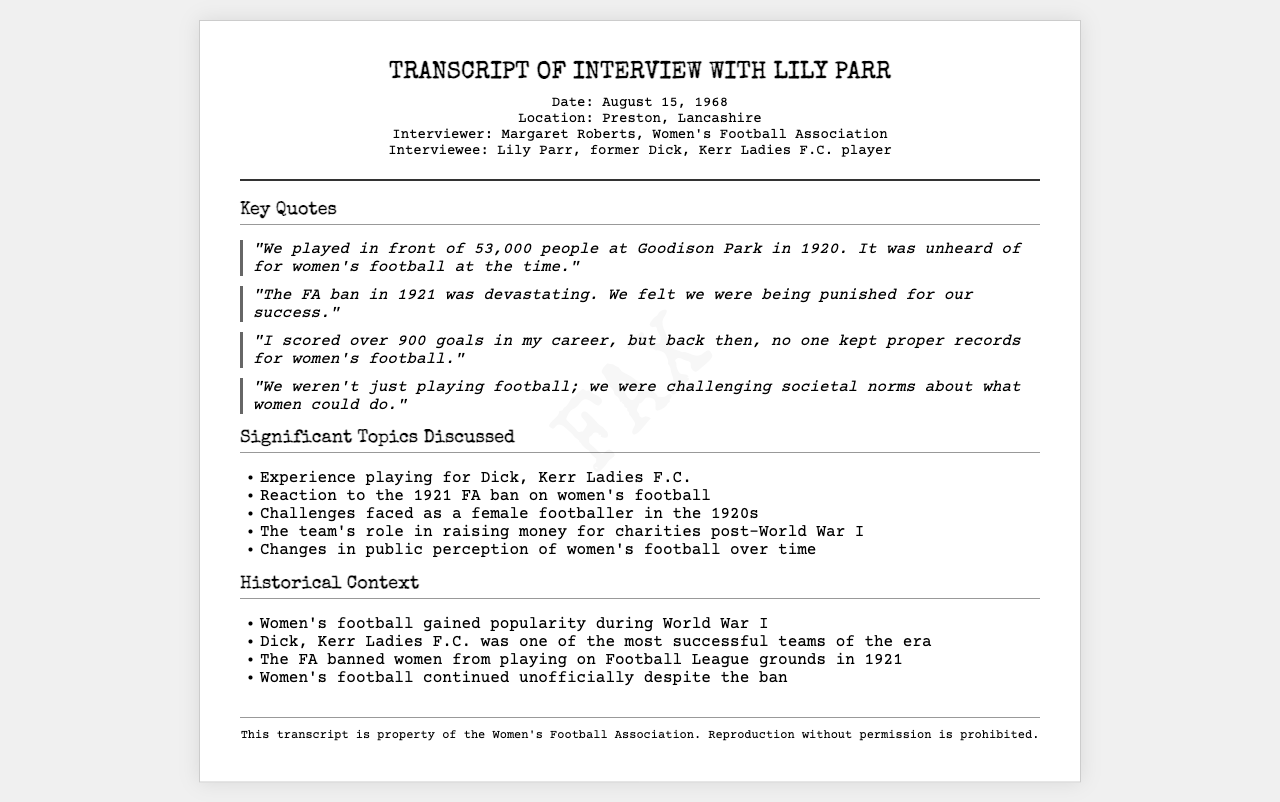What was the date of the interview? The date of the interview is explicitly mentioned in the document.
Answer: August 15, 1968 Who was the interviewer? The name of the interviewer is specified in the document.
Answer: Margaret Roberts What is the name of the team Lily Parr played for? The name of the team is clearly stated in the document.
Answer: Dick, Kerr Ladies F.C How many goals did Lily Parr claim to have scored in her career? The document provides the exact number of goals scored by Lily Parr during her career.
Answer: over 900 goals What significant event happened in 1921 concerning women's football? The document discusses a major event that affected women's football in that year.
Answer: FA ban What was the attendance at Goodison Park in 1920 for a women's football match? The document provides a specific number for the attendance at the match.
Answer: 53,000 people What societal aspect did Lily Parr feel they were challenging through football? The document indicates what was being challenged by their participation in football.
Answer: societal norms What was the era during which women's football gained popularity mentioned in the document? The document states the specific period when interest in women's football increased.
Answer: World War I What role did Dick, Kerr Ladies F.C. play post-World War I according to the document? The document mentions the team's contribution following the war.
Answer: raising money for charities 